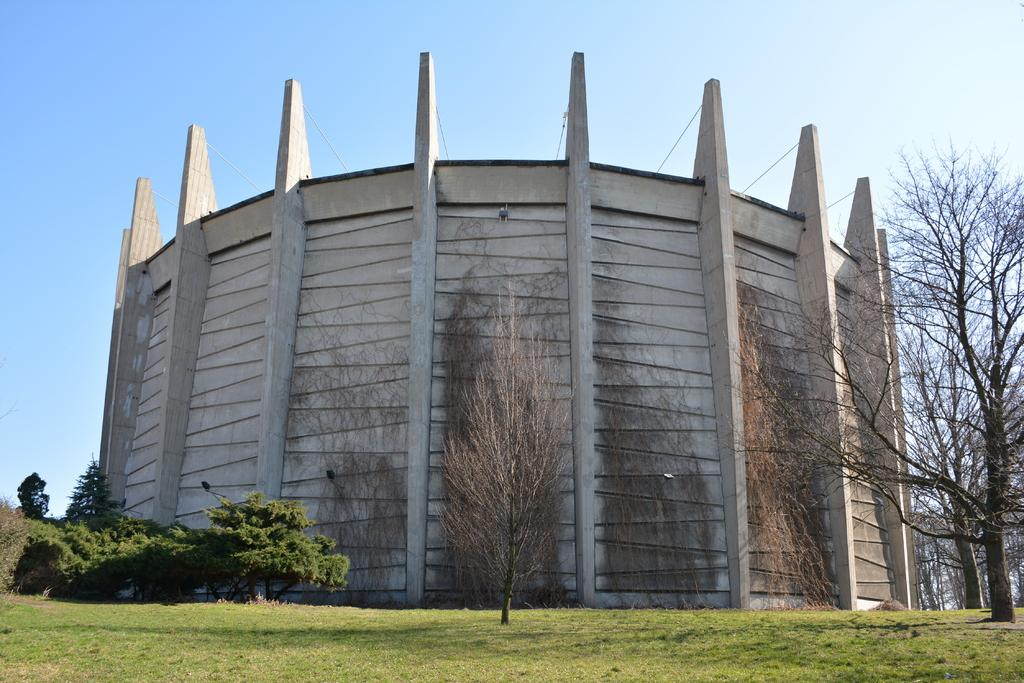What type of structure is present in the image? There is a building in the image. What can be seen on the ground in the image? There are trees and grass on the ground in the image. What is visible in the background of the image? The sky is visible in the background of the image. How many cats are sitting on the roof of the building in the image? There are no cats present in the image; only the building, trees, grass, and sky are visible. 